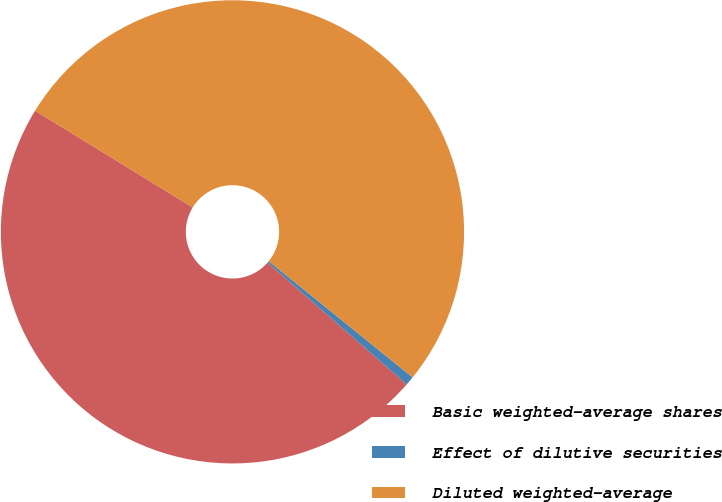Convert chart. <chart><loc_0><loc_0><loc_500><loc_500><pie_chart><fcel>Basic weighted-average shares<fcel>Effect of dilutive securities<fcel>Diluted weighted-average<nl><fcel>47.32%<fcel>0.63%<fcel>52.05%<nl></chart> 